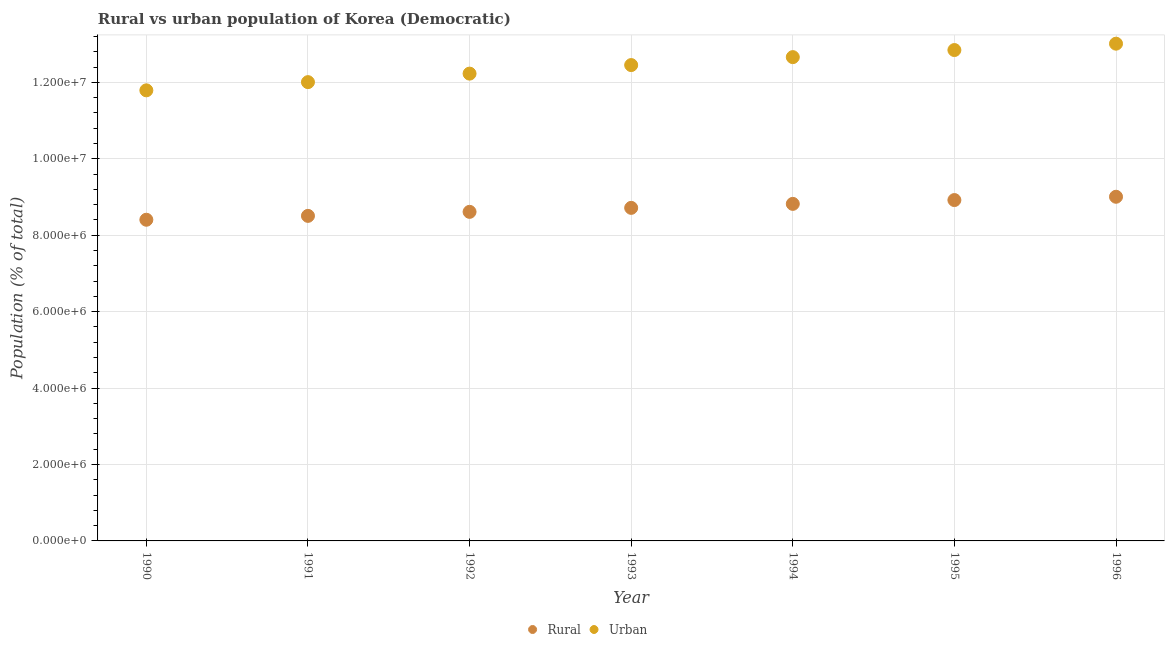How many different coloured dotlines are there?
Offer a very short reply. 2. What is the rural population density in 1991?
Your response must be concise. 8.51e+06. Across all years, what is the maximum rural population density?
Keep it short and to the point. 9.01e+06. Across all years, what is the minimum rural population density?
Provide a short and direct response. 8.40e+06. What is the total urban population density in the graph?
Give a very brief answer. 8.70e+07. What is the difference between the urban population density in 1990 and that in 1996?
Offer a terse response. -1.22e+06. What is the difference between the rural population density in 1994 and the urban population density in 1993?
Provide a succinct answer. -3.63e+06. What is the average rural population density per year?
Your response must be concise. 8.71e+06. In the year 1992, what is the difference between the urban population density and rural population density?
Make the answer very short. 3.62e+06. What is the ratio of the rural population density in 1992 to that in 1995?
Provide a succinct answer. 0.97. Is the rural population density in 1991 less than that in 1993?
Give a very brief answer. Yes. What is the difference between the highest and the second highest rural population density?
Ensure brevity in your answer.  8.62e+04. What is the difference between the highest and the lowest rural population density?
Keep it short and to the point. 6.01e+05. Is the urban population density strictly less than the rural population density over the years?
Keep it short and to the point. No. How many years are there in the graph?
Provide a short and direct response. 7. Are the values on the major ticks of Y-axis written in scientific E-notation?
Your answer should be compact. Yes. Does the graph contain any zero values?
Offer a very short reply. No. Does the graph contain grids?
Offer a terse response. Yes. Where does the legend appear in the graph?
Your answer should be compact. Bottom center. What is the title of the graph?
Keep it short and to the point. Rural vs urban population of Korea (Democratic). Does "Register a property" appear as one of the legend labels in the graph?
Your response must be concise. No. What is the label or title of the X-axis?
Give a very brief answer. Year. What is the label or title of the Y-axis?
Provide a succinct answer. Population (% of total). What is the Population (% of total) of Rural in 1990?
Provide a succinct answer. 8.40e+06. What is the Population (% of total) in Urban in 1990?
Make the answer very short. 1.18e+07. What is the Population (% of total) of Rural in 1991?
Make the answer very short. 8.51e+06. What is the Population (% of total) of Urban in 1991?
Ensure brevity in your answer.  1.20e+07. What is the Population (% of total) of Rural in 1992?
Offer a very short reply. 8.61e+06. What is the Population (% of total) in Urban in 1992?
Ensure brevity in your answer.  1.22e+07. What is the Population (% of total) of Rural in 1993?
Provide a short and direct response. 8.71e+06. What is the Population (% of total) in Urban in 1993?
Your answer should be compact. 1.25e+07. What is the Population (% of total) of Rural in 1994?
Give a very brief answer. 8.82e+06. What is the Population (% of total) of Urban in 1994?
Give a very brief answer. 1.27e+07. What is the Population (% of total) in Rural in 1995?
Offer a very short reply. 8.92e+06. What is the Population (% of total) of Urban in 1995?
Provide a succinct answer. 1.28e+07. What is the Population (% of total) in Rural in 1996?
Provide a short and direct response. 9.01e+06. What is the Population (% of total) in Urban in 1996?
Ensure brevity in your answer.  1.30e+07. Across all years, what is the maximum Population (% of total) in Rural?
Your answer should be compact. 9.01e+06. Across all years, what is the maximum Population (% of total) in Urban?
Provide a succinct answer. 1.30e+07. Across all years, what is the minimum Population (% of total) in Rural?
Keep it short and to the point. 8.40e+06. Across all years, what is the minimum Population (% of total) of Urban?
Your answer should be very brief. 1.18e+07. What is the total Population (% of total) in Rural in the graph?
Your answer should be very brief. 6.10e+07. What is the total Population (% of total) of Urban in the graph?
Make the answer very short. 8.70e+07. What is the difference between the Population (% of total) of Rural in 1990 and that in 1991?
Offer a very short reply. -1.01e+05. What is the difference between the Population (% of total) of Urban in 1990 and that in 1991?
Offer a terse response. -2.15e+05. What is the difference between the Population (% of total) of Rural in 1990 and that in 1992?
Your answer should be compact. -2.06e+05. What is the difference between the Population (% of total) of Urban in 1990 and that in 1992?
Provide a succinct answer. -4.37e+05. What is the difference between the Population (% of total) of Rural in 1990 and that in 1993?
Make the answer very short. -3.11e+05. What is the difference between the Population (% of total) of Urban in 1990 and that in 1993?
Offer a terse response. -6.61e+05. What is the difference between the Population (% of total) in Rural in 1990 and that in 1994?
Offer a very short reply. -4.15e+05. What is the difference between the Population (% of total) of Urban in 1990 and that in 1994?
Keep it short and to the point. -8.69e+05. What is the difference between the Population (% of total) of Rural in 1990 and that in 1995?
Offer a very short reply. -5.15e+05. What is the difference between the Population (% of total) of Urban in 1990 and that in 1995?
Give a very brief answer. -1.05e+06. What is the difference between the Population (% of total) of Rural in 1990 and that in 1996?
Make the answer very short. -6.01e+05. What is the difference between the Population (% of total) in Urban in 1990 and that in 1996?
Offer a terse response. -1.22e+06. What is the difference between the Population (% of total) of Rural in 1991 and that in 1992?
Provide a short and direct response. -1.05e+05. What is the difference between the Population (% of total) in Urban in 1991 and that in 1992?
Your response must be concise. -2.23e+05. What is the difference between the Population (% of total) of Rural in 1991 and that in 1993?
Keep it short and to the point. -2.10e+05. What is the difference between the Population (% of total) in Urban in 1991 and that in 1993?
Keep it short and to the point. -4.46e+05. What is the difference between the Population (% of total) of Rural in 1991 and that in 1994?
Provide a short and direct response. -3.14e+05. What is the difference between the Population (% of total) in Urban in 1991 and that in 1994?
Your answer should be compact. -6.54e+05. What is the difference between the Population (% of total) of Rural in 1991 and that in 1995?
Keep it short and to the point. -4.14e+05. What is the difference between the Population (% of total) in Urban in 1991 and that in 1995?
Give a very brief answer. -8.40e+05. What is the difference between the Population (% of total) of Rural in 1991 and that in 1996?
Offer a very short reply. -5.00e+05. What is the difference between the Population (% of total) in Urban in 1991 and that in 1996?
Give a very brief answer. -1.01e+06. What is the difference between the Population (% of total) in Rural in 1992 and that in 1993?
Ensure brevity in your answer.  -1.04e+05. What is the difference between the Population (% of total) in Urban in 1992 and that in 1993?
Make the answer very short. -2.24e+05. What is the difference between the Population (% of total) in Rural in 1992 and that in 1994?
Make the answer very short. -2.09e+05. What is the difference between the Population (% of total) in Urban in 1992 and that in 1994?
Your answer should be very brief. -4.32e+05. What is the difference between the Population (% of total) in Rural in 1992 and that in 1995?
Keep it short and to the point. -3.09e+05. What is the difference between the Population (% of total) in Urban in 1992 and that in 1995?
Give a very brief answer. -6.17e+05. What is the difference between the Population (% of total) of Rural in 1992 and that in 1996?
Offer a terse response. -3.95e+05. What is the difference between the Population (% of total) in Urban in 1992 and that in 1996?
Provide a short and direct response. -7.84e+05. What is the difference between the Population (% of total) of Rural in 1993 and that in 1994?
Offer a very short reply. -1.04e+05. What is the difference between the Population (% of total) of Urban in 1993 and that in 1994?
Offer a terse response. -2.08e+05. What is the difference between the Population (% of total) in Rural in 1993 and that in 1995?
Provide a short and direct response. -2.04e+05. What is the difference between the Population (% of total) in Urban in 1993 and that in 1995?
Provide a succinct answer. -3.93e+05. What is the difference between the Population (% of total) of Rural in 1993 and that in 1996?
Keep it short and to the point. -2.90e+05. What is the difference between the Population (% of total) in Urban in 1993 and that in 1996?
Make the answer very short. -5.60e+05. What is the difference between the Population (% of total) of Rural in 1994 and that in 1995?
Your answer should be compact. -9.99e+04. What is the difference between the Population (% of total) in Urban in 1994 and that in 1995?
Offer a terse response. -1.85e+05. What is the difference between the Population (% of total) in Rural in 1994 and that in 1996?
Your response must be concise. -1.86e+05. What is the difference between the Population (% of total) in Urban in 1994 and that in 1996?
Keep it short and to the point. -3.52e+05. What is the difference between the Population (% of total) of Rural in 1995 and that in 1996?
Keep it short and to the point. -8.62e+04. What is the difference between the Population (% of total) of Urban in 1995 and that in 1996?
Keep it short and to the point. -1.67e+05. What is the difference between the Population (% of total) in Rural in 1990 and the Population (% of total) in Urban in 1991?
Ensure brevity in your answer.  -3.60e+06. What is the difference between the Population (% of total) of Rural in 1990 and the Population (% of total) of Urban in 1992?
Your answer should be compact. -3.82e+06. What is the difference between the Population (% of total) in Rural in 1990 and the Population (% of total) in Urban in 1993?
Your answer should be compact. -4.05e+06. What is the difference between the Population (% of total) in Rural in 1990 and the Population (% of total) in Urban in 1994?
Give a very brief answer. -4.26e+06. What is the difference between the Population (% of total) in Rural in 1990 and the Population (% of total) in Urban in 1995?
Give a very brief answer. -4.44e+06. What is the difference between the Population (% of total) in Rural in 1990 and the Population (% of total) in Urban in 1996?
Your answer should be very brief. -4.61e+06. What is the difference between the Population (% of total) of Rural in 1991 and the Population (% of total) of Urban in 1992?
Your answer should be compact. -3.72e+06. What is the difference between the Population (% of total) in Rural in 1991 and the Population (% of total) in Urban in 1993?
Give a very brief answer. -3.95e+06. What is the difference between the Population (% of total) of Rural in 1991 and the Population (% of total) of Urban in 1994?
Give a very brief answer. -4.15e+06. What is the difference between the Population (% of total) in Rural in 1991 and the Population (% of total) in Urban in 1995?
Your answer should be very brief. -4.34e+06. What is the difference between the Population (% of total) of Rural in 1991 and the Population (% of total) of Urban in 1996?
Your answer should be compact. -4.51e+06. What is the difference between the Population (% of total) of Rural in 1992 and the Population (% of total) of Urban in 1993?
Ensure brevity in your answer.  -3.84e+06. What is the difference between the Population (% of total) of Rural in 1992 and the Population (% of total) of Urban in 1994?
Keep it short and to the point. -4.05e+06. What is the difference between the Population (% of total) of Rural in 1992 and the Population (% of total) of Urban in 1995?
Your answer should be very brief. -4.23e+06. What is the difference between the Population (% of total) in Rural in 1992 and the Population (% of total) in Urban in 1996?
Your answer should be compact. -4.40e+06. What is the difference between the Population (% of total) of Rural in 1993 and the Population (% of total) of Urban in 1994?
Provide a short and direct response. -3.94e+06. What is the difference between the Population (% of total) in Rural in 1993 and the Population (% of total) in Urban in 1995?
Keep it short and to the point. -4.13e+06. What is the difference between the Population (% of total) of Rural in 1993 and the Population (% of total) of Urban in 1996?
Offer a terse response. -4.30e+06. What is the difference between the Population (% of total) in Rural in 1994 and the Population (% of total) in Urban in 1995?
Offer a terse response. -4.03e+06. What is the difference between the Population (% of total) of Rural in 1994 and the Population (% of total) of Urban in 1996?
Provide a succinct answer. -4.19e+06. What is the difference between the Population (% of total) of Rural in 1995 and the Population (% of total) of Urban in 1996?
Offer a terse response. -4.09e+06. What is the average Population (% of total) in Rural per year?
Offer a terse response. 8.71e+06. What is the average Population (% of total) of Urban per year?
Ensure brevity in your answer.  1.24e+07. In the year 1990, what is the difference between the Population (% of total) in Rural and Population (% of total) in Urban?
Keep it short and to the point. -3.39e+06. In the year 1991, what is the difference between the Population (% of total) of Rural and Population (% of total) of Urban?
Ensure brevity in your answer.  -3.50e+06. In the year 1992, what is the difference between the Population (% of total) in Rural and Population (% of total) in Urban?
Your response must be concise. -3.62e+06. In the year 1993, what is the difference between the Population (% of total) in Rural and Population (% of total) in Urban?
Offer a very short reply. -3.74e+06. In the year 1994, what is the difference between the Population (% of total) in Rural and Population (% of total) in Urban?
Provide a short and direct response. -3.84e+06. In the year 1995, what is the difference between the Population (% of total) in Rural and Population (% of total) in Urban?
Make the answer very short. -3.93e+06. In the year 1996, what is the difference between the Population (% of total) in Rural and Population (% of total) in Urban?
Give a very brief answer. -4.01e+06. What is the ratio of the Population (% of total) of Urban in 1990 to that in 1991?
Ensure brevity in your answer.  0.98. What is the ratio of the Population (% of total) of Urban in 1990 to that in 1992?
Keep it short and to the point. 0.96. What is the ratio of the Population (% of total) of Rural in 1990 to that in 1993?
Your response must be concise. 0.96. What is the ratio of the Population (% of total) of Urban in 1990 to that in 1993?
Make the answer very short. 0.95. What is the ratio of the Population (% of total) of Rural in 1990 to that in 1994?
Make the answer very short. 0.95. What is the ratio of the Population (% of total) in Urban in 1990 to that in 1994?
Provide a succinct answer. 0.93. What is the ratio of the Population (% of total) of Rural in 1990 to that in 1995?
Ensure brevity in your answer.  0.94. What is the ratio of the Population (% of total) of Urban in 1990 to that in 1995?
Your response must be concise. 0.92. What is the ratio of the Population (% of total) of Rural in 1990 to that in 1996?
Your answer should be very brief. 0.93. What is the ratio of the Population (% of total) of Urban in 1990 to that in 1996?
Make the answer very short. 0.91. What is the ratio of the Population (% of total) of Rural in 1991 to that in 1992?
Offer a very short reply. 0.99. What is the ratio of the Population (% of total) of Urban in 1991 to that in 1992?
Give a very brief answer. 0.98. What is the ratio of the Population (% of total) in Rural in 1991 to that in 1993?
Make the answer very short. 0.98. What is the ratio of the Population (% of total) in Urban in 1991 to that in 1993?
Your response must be concise. 0.96. What is the ratio of the Population (% of total) of Rural in 1991 to that in 1994?
Your response must be concise. 0.96. What is the ratio of the Population (% of total) in Urban in 1991 to that in 1994?
Keep it short and to the point. 0.95. What is the ratio of the Population (% of total) in Rural in 1991 to that in 1995?
Provide a succinct answer. 0.95. What is the ratio of the Population (% of total) in Urban in 1991 to that in 1995?
Offer a very short reply. 0.93. What is the ratio of the Population (% of total) of Rural in 1991 to that in 1996?
Offer a terse response. 0.94. What is the ratio of the Population (% of total) in Urban in 1991 to that in 1996?
Your response must be concise. 0.92. What is the ratio of the Population (% of total) of Urban in 1992 to that in 1993?
Provide a short and direct response. 0.98. What is the ratio of the Population (% of total) in Rural in 1992 to that in 1994?
Offer a terse response. 0.98. What is the ratio of the Population (% of total) of Urban in 1992 to that in 1994?
Provide a short and direct response. 0.97. What is the ratio of the Population (% of total) in Rural in 1992 to that in 1995?
Offer a terse response. 0.97. What is the ratio of the Population (% of total) of Rural in 1992 to that in 1996?
Your response must be concise. 0.96. What is the ratio of the Population (% of total) of Urban in 1992 to that in 1996?
Offer a very short reply. 0.94. What is the ratio of the Population (% of total) in Rural in 1993 to that in 1994?
Give a very brief answer. 0.99. What is the ratio of the Population (% of total) in Urban in 1993 to that in 1994?
Give a very brief answer. 0.98. What is the ratio of the Population (% of total) in Rural in 1993 to that in 1995?
Offer a terse response. 0.98. What is the ratio of the Population (% of total) in Urban in 1993 to that in 1995?
Give a very brief answer. 0.97. What is the ratio of the Population (% of total) of Urban in 1993 to that in 1996?
Make the answer very short. 0.96. What is the ratio of the Population (% of total) in Rural in 1994 to that in 1995?
Your answer should be compact. 0.99. What is the ratio of the Population (% of total) of Urban in 1994 to that in 1995?
Keep it short and to the point. 0.99. What is the ratio of the Population (% of total) of Rural in 1994 to that in 1996?
Give a very brief answer. 0.98. What is the ratio of the Population (% of total) of Urban in 1994 to that in 1996?
Your response must be concise. 0.97. What is the ratio of the Population (% of total) in Rural in 1995 to that in 1996?
Give a very brief answer. 0.99. What is the ratio of the Population (% of total) in Urban in 1995 to that in 1996?
Provide a succinct answer. 0.99. What is the difference between the highest and the second highest Population (% of total) in Rural?
Your response must be concise. 8.62e+04. What is the difference between the highest and the second highest Population (% of total) of Urban?
Offer a terse response. 1.67e+05. What is the difference between the highest and the lowest Population (% of total) of Rural?
Your answer should be very brief. 6.01e+05. What is the difference between the highest and the lowest Population (% of total) in Urban?
Your answer should be very brief. 1.22e+06. 